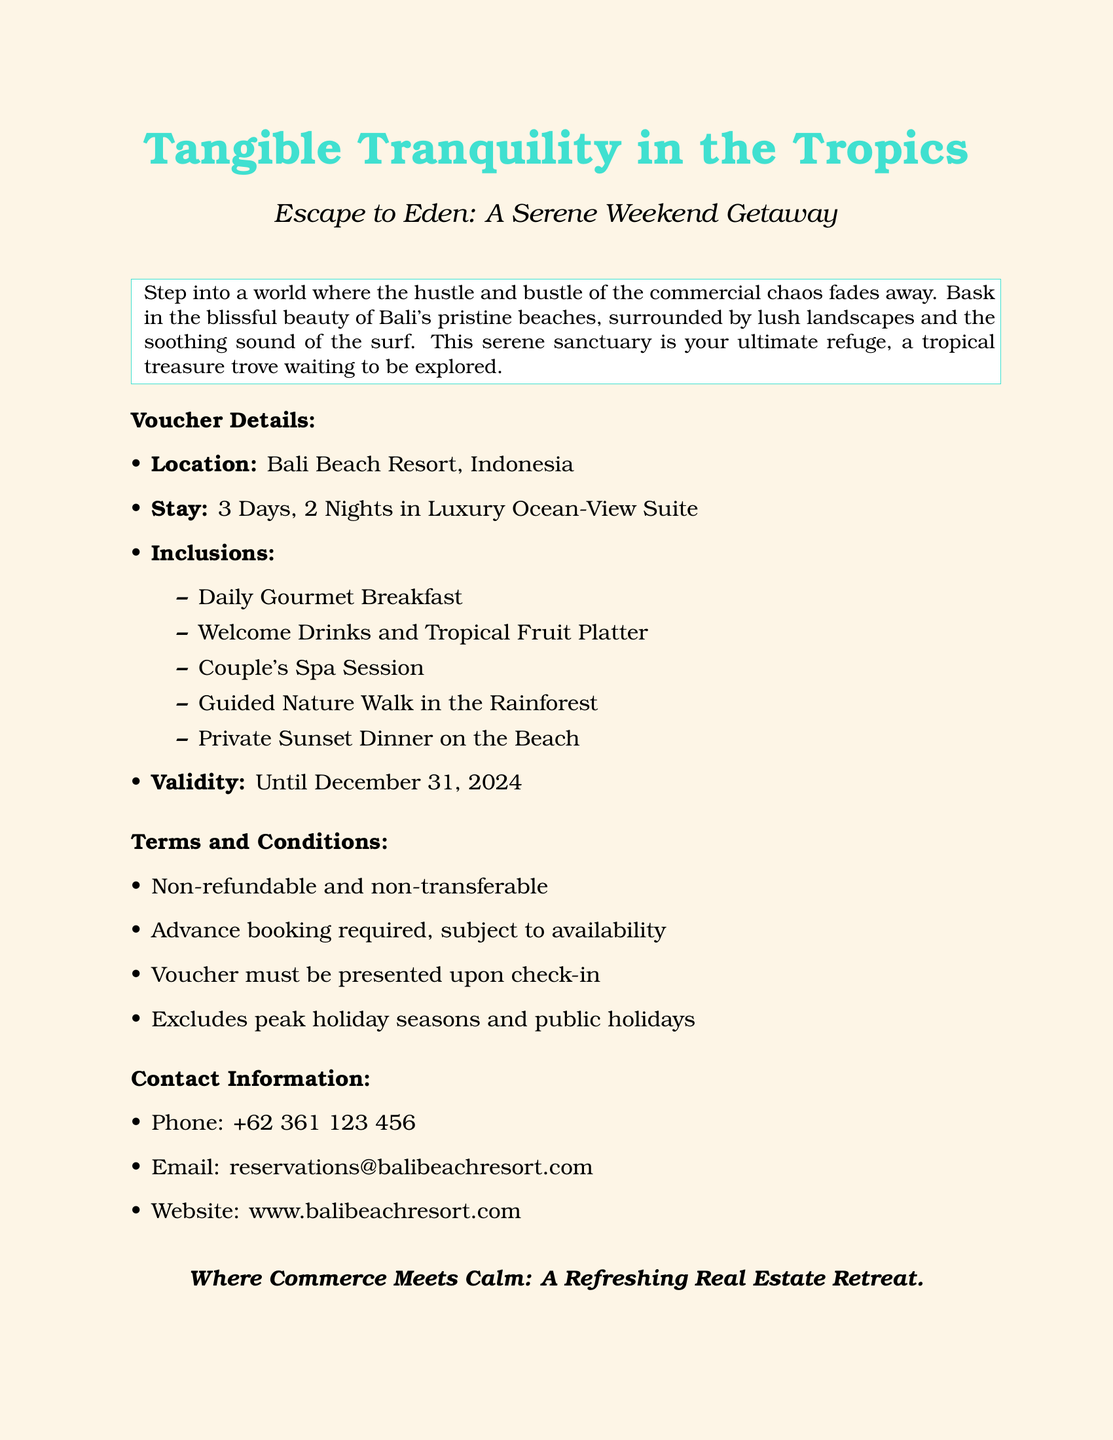What is the location of the resort? The location is specifically mentioned in the voucher details section of the document as Bali Beach Resort, Indonesia.
Answer: Bali Beach Resort, Indonesia How many nights is the stay? The stay is outlined in the voucher details as lasting for 3 days and 2 nights in a luxury suite.
Answer: 2 Nights What spa service is included? The inclusions list a specific service, which is a couple's spa session.
Answer: Couple's Spa Session What must be presented upon check-in? The terms and conditions specify that the voucher must be presented upon check-in.
Answer: Voucher When does the voucher expire? The validity is stated clearly, indicating the expiration date as December 31, 2024.
Answer: December 31, 2024 What type of dinner is offered? The inclusions detail a specific type of dining experience provided, which is a private sunset dinner on the beach.
Answer: Private Sunset Dinner What is the main theme of the document? The title and subtitle highlight the theme of relaxation and escape, emphasizing Tangible Tranquility in the Tropics.
Answer: Tangible Tranquility in the Tropics Is the voucher refundable? The terms and conditions explicitly state that the voucher is non-refundable.
Answer: Non-refundable What is included in the welcome package? The inclusions specify that the welcome package consists of welcome drinks and a tropical fruit platter.
Answer: Welcome Drinks and Tropical Fruit Platter 